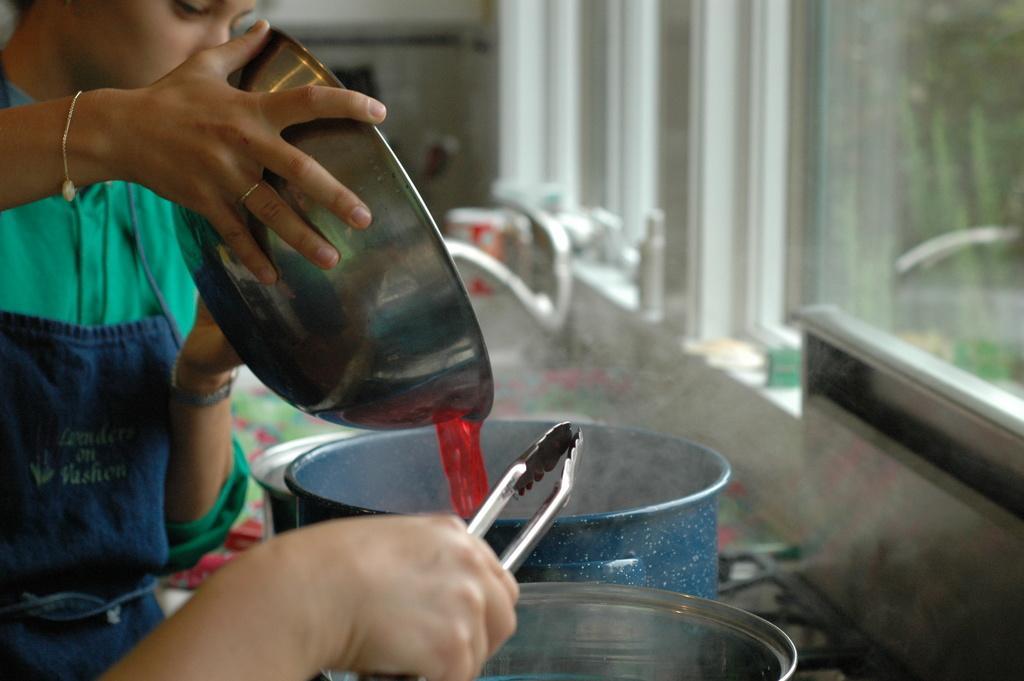In one or two sentences, can you explain what this image depicts? This picture seems to be clicked inside the room. On the right corner we can see the windows and through the windows we can see the green leaves and some other items. On the left we can see the persons seems to be cooking and we can see the utensils and some other items. 